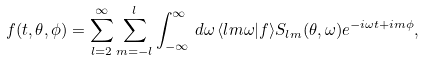Convert formula to latex. <formula><loc_0><loc_0><loc_500><loc_500>f ( t , \theta , \phi ) = \sum _ { l = 2 } ^ { \infty } \sum _ { m = - l } ^ { l } \int _ { - \infty } ^ { \infty } \, d \omega \, \langle l m \omega | f \rangle S _ { l m } ( \theta , \omega ) e ^ { - i \omega t + i m \phi } ,</formula> 